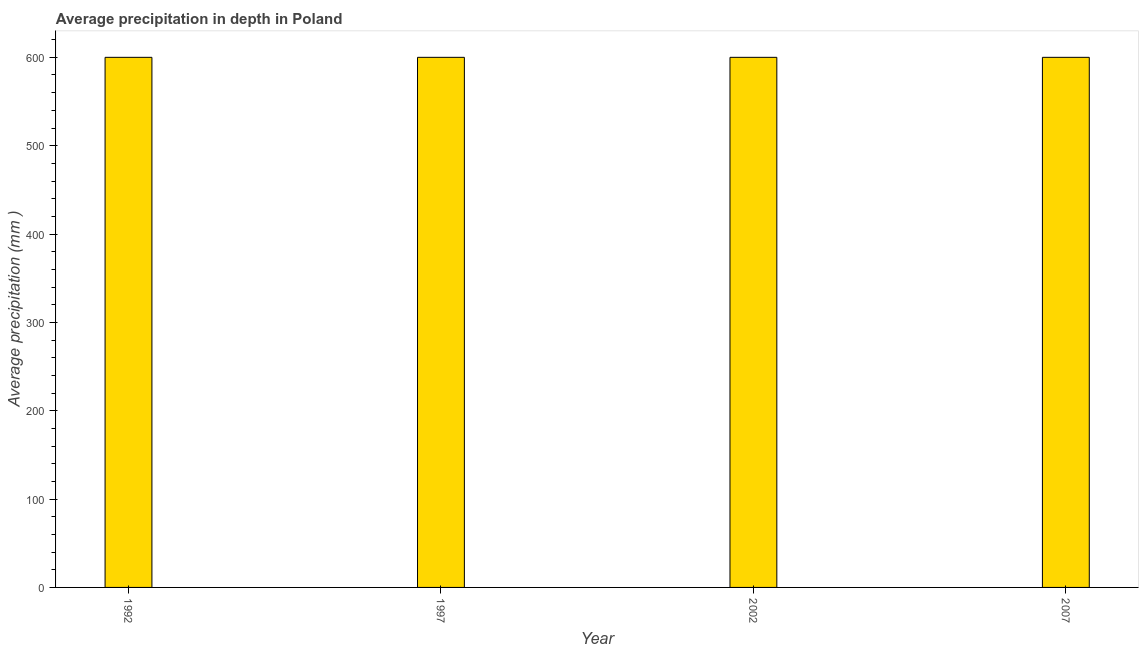Does the graph contain any zero values?
Provide a short and direct response. No. Does the graph contain grids?
Provide a succinct answer. No. What is the title of the graph?
Offer a terse response. Average precipitation in depth in Poland. What is the label or title of the X-axis?
Offer a terse response. Year. What is the label or title of the Y-axis?
Your response must be concise. Average precipitation (mm ). What is the average precipitation in depth in 1997?
Your answer should be very brief. 600. Across all years, what is the maximum average precipitation in depth?
Ensure brevity in your answer.  600. Across all years, what is the minimum average precipitation in depth?
Your answer should be very brief. 600. In which year was the average precipitation in depth maximum?
Keep it short and to the point. 1992. In which year was the average precipitation in depth minimum?
Offer a terse response. 1992. What is the sum of the average precipitation in depth?
Give a very brief answer. 2400. What is the difference between the average precipitation in depth in 1997 and 2002?
Offer a very short reply. 0. What is the average average precipitation in depth per year?
Keep it short and to the point. 600. What is the median average precipitation in depth?
Keep it short and to the point. 600. Do a majority of the years between 2002 and 2007 (inclusive) have average precipitation in depth greater than 520 mm?
Your answer should be compact. Yes. What is the ratio of the average precipitation in depth in 1997 to that in 2002?
Offer a very short reply. 1. Is the difference between the average precipitation in depth in 2002 and 2007 greater than the difference between any two years?
Your answer should be compact. Yes. What is the difference between the highest and the second highest average precipitation in depth?
Offer a very short reply. 0. Is the sum of the average precipitation in depth in 2002 and 2007 greater than the maximum average precipitation in depth across all years?
Provide a succinct answer. Yes. What is the difference between two consecutive major ticks on the Y-axis?
Ensure brevity in your answer.  100. Are the values on the major ticks of Y-axis written in scientific E-notation?
Ensure brevity in your answer.  No. What is the Average precipitation (mm ) of 1992?
Your answer should be very brief. 600. What is the Average precipitation (mm ) of 1997?
Offer a terse response. 600. What is the Average precipitation (mm ) of 2002?
Give a very brief answer. 600. What is the Average precipitation (mm ) of 2007?
Offer a very short reply. 600. What is the difference between the Average precipitation (mm ) in 1992 and 1997?
Your answer should be compact. 0. What is the difference between the Average precipitation (mm ) in 1997 and 2002?
Provide a succinct answer. 0. What is the difference between the Average precipitation (mm ) in 2002 and 2007?
Offer a very short reply. 0. What is the ratio of the Average precipitation (mm ) in 1992 to that in 1997?
Ensure brevity in your answer.  1. What is the ratio of the Average precipitation (mm ) in 1992 to that in 2002?
Your response must be concise. 1. What is the ratio of the Average precipitation (mm ) in 1997 to that in 2002?
Your answer should be very brief. 1. What is the ratio of the Average precipitation (mm ) in 2002 to that in 2007?
Give a very brief answer. 1. 